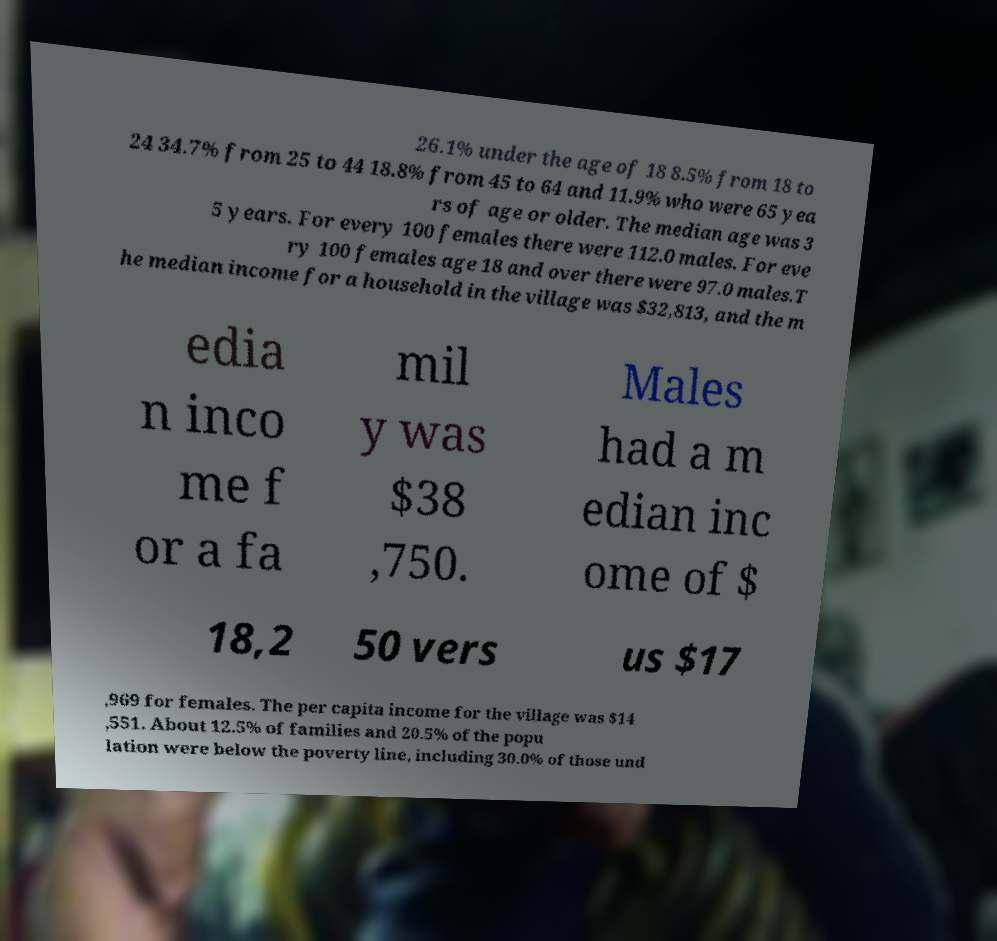Can you accurately transcribe the text from the provided image for me? 26.1% under the age of 18 8.5% from 18 to 24 34.7% from 25 to 44 18.8% from 45 to 64 and 11.9% who were 65 yea rs of age or older. The median age was 3 5 years. For every 100 females there were 112.0 males. For eve ry 100 females age 18 and over there were 97.0 males.T he median income for a household in the village was $32,813, and the m edia n inco me f or a fa mil y was $38 ,750. Males had a m edian inc ome of $ 18,2 50 vers us $17 ,969 for females. The per capita income for the village was $14 ,551. About 12.5% of families and 20.5% of the popu lation were below the poverty line, including 30.0% of those und 